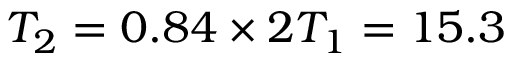Convert formula to latex. <formula><loc_0><loc_0><loc_500><loc_500>T _ { 2 } = 0 . 8 4 \times 2 T _ { 1 } = 1 5 . 3</formula> 